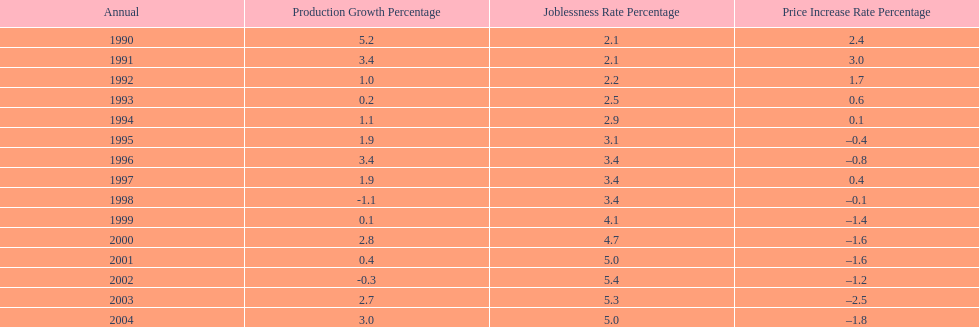When in the 1990's did the inflation rate first become negative? 1995. 